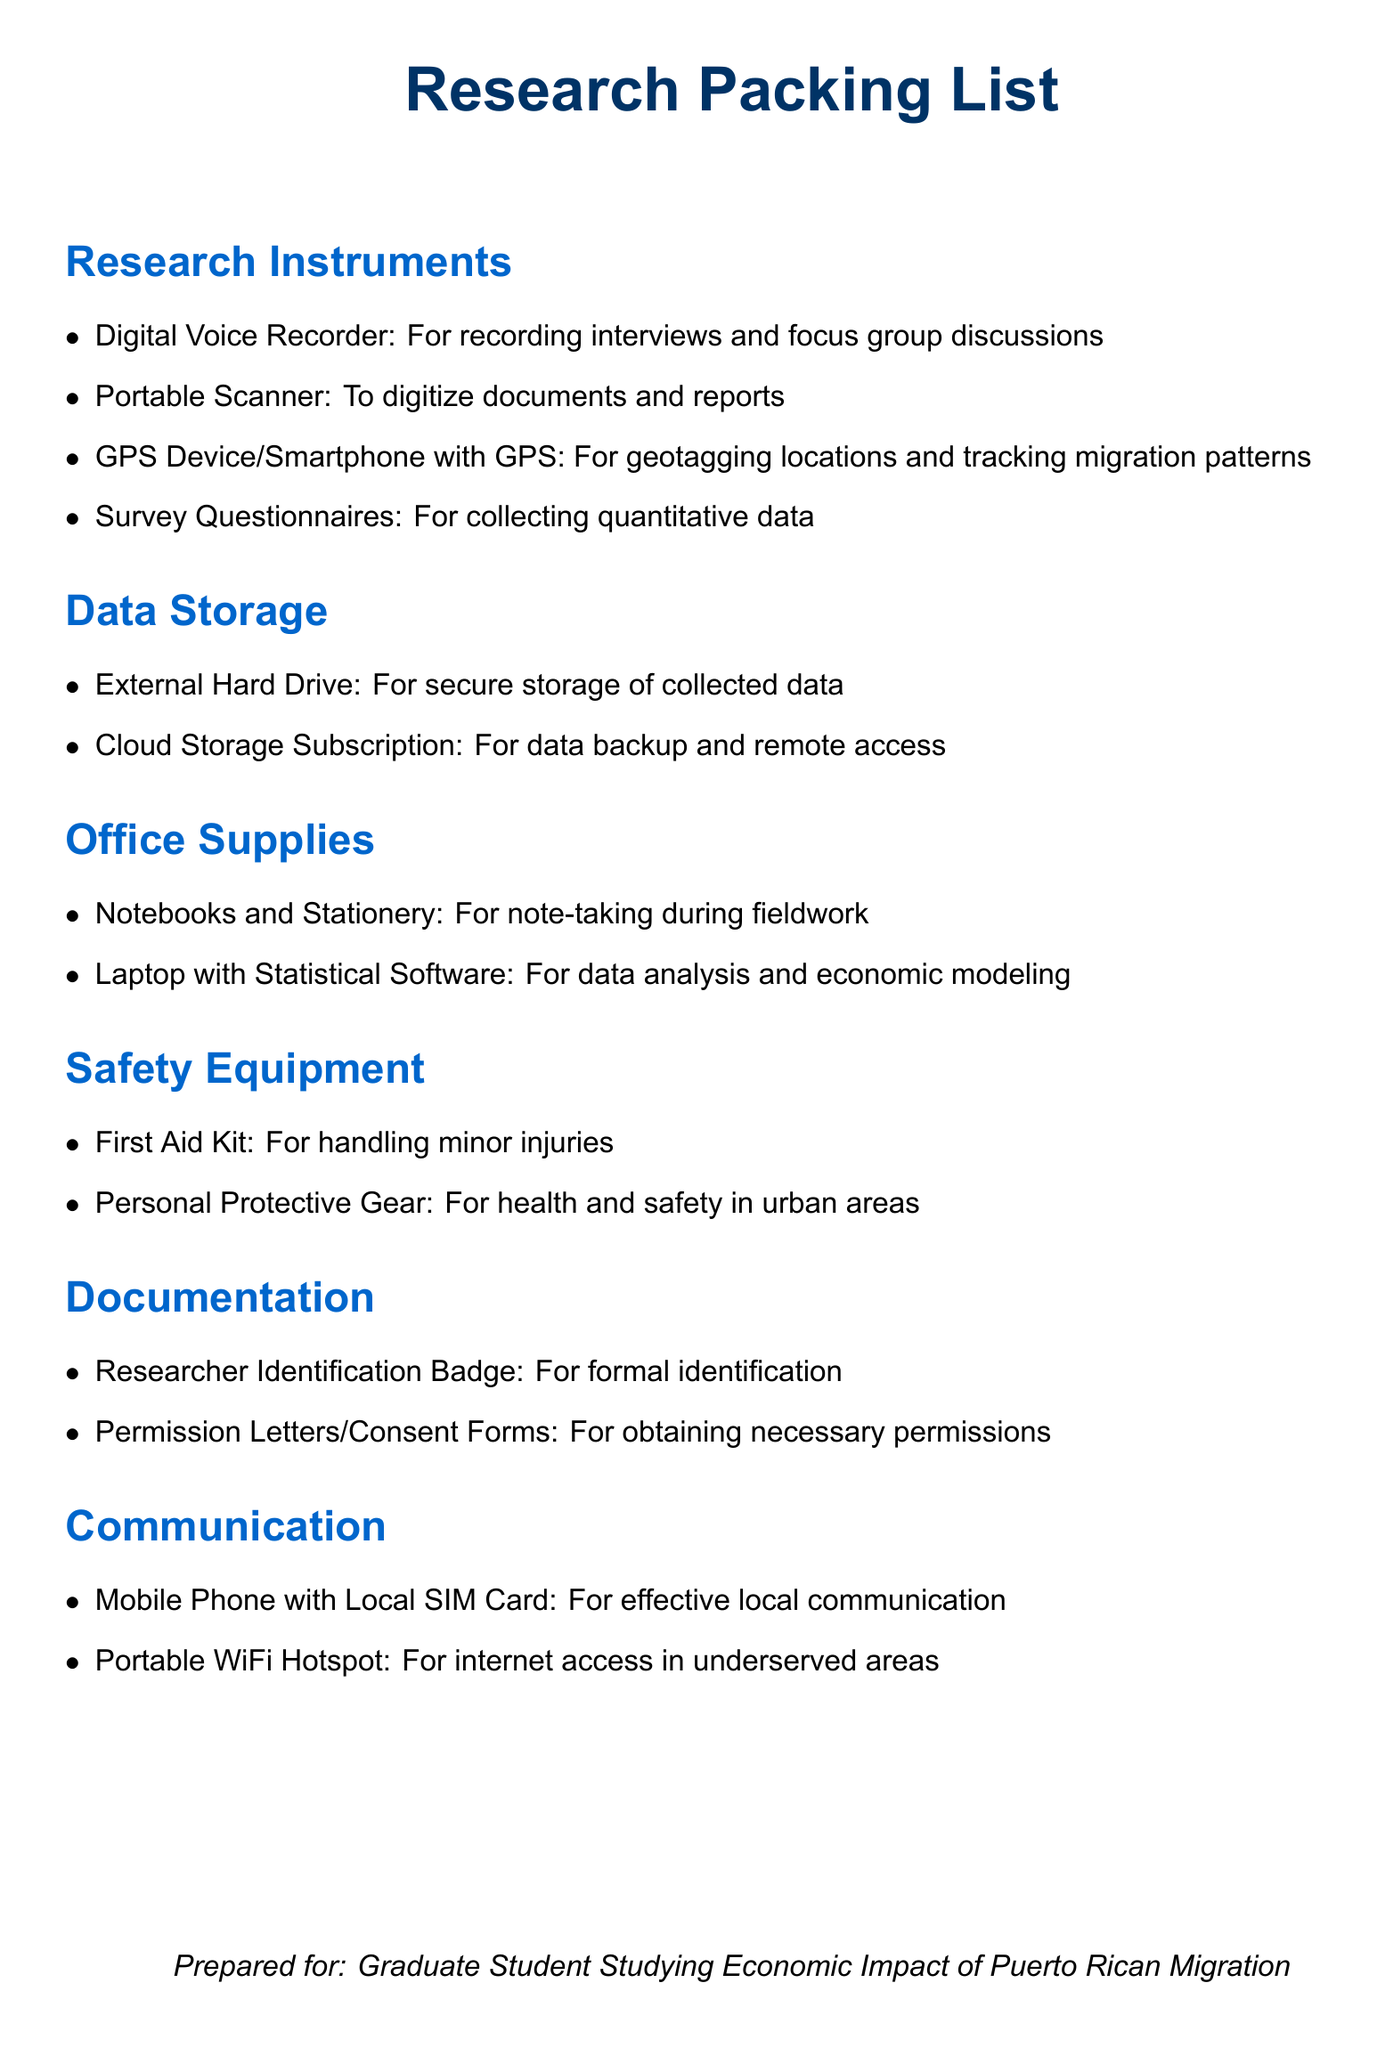What is the main title of the document? The main title is clearly stated at the beginning of the document and it summarizes its purpose.
Answer: Research Packing List How many categories of equipment are listed? The document lists different categories under which the equipment is organized, which can be counted.
Answer: 6 What type of storage solution is mentioned for data backup? The document specifies a method for ensuring data is safely stored, referring to a modern approach to data security.
Answer: Cloud Storage Subscription What safety item is included in the packing list? The document outlines various requirements for safety, particularly focused on health and wellness during field studies.
Answer: First Aid Kit Which electronic device is specified for recording data during interviews? The document indicates a specific instrument used to capture verbal information in gatherings, particularly for qualitative research.
Answer: Digital Voice Recorder What personal item is suggested for effective communication? The packing list highlights a critical item necessary for staying in touch, especially in local environments.
Answer: Mobile Phone with Local SIM Card Why is a portable scanner included in the list? The inclusion of this item suggests a need for digitization of physical documents during fieldwork.
Answer: To digitize documents and reports What type of gear is recommended for health and safety? This question pertains to protective measures suggested in the document for personal well-being in urban settings.
Answer: Personal Protective Gear 